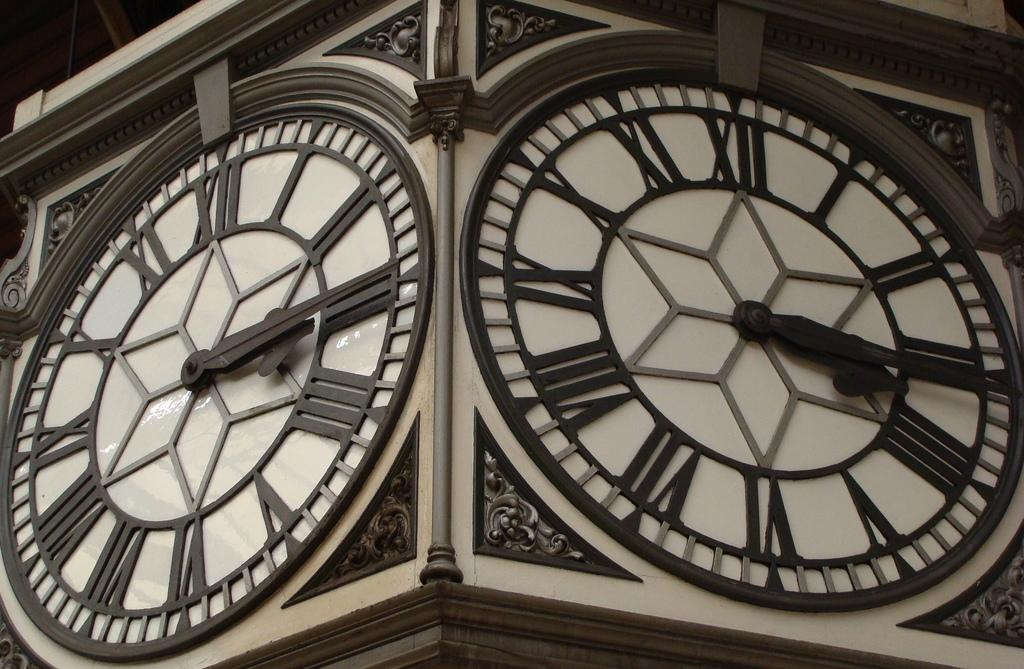What is the main structure visible in the image? There is a clock tower in the image. How many oranges are balanced on top of the clock tower in the image? There are no oranges present in the image, and therefore no such activity can be observed. 